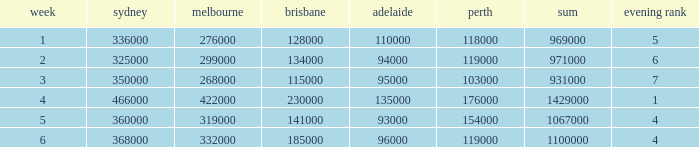What was the total rating on week 3?  931000.0. 